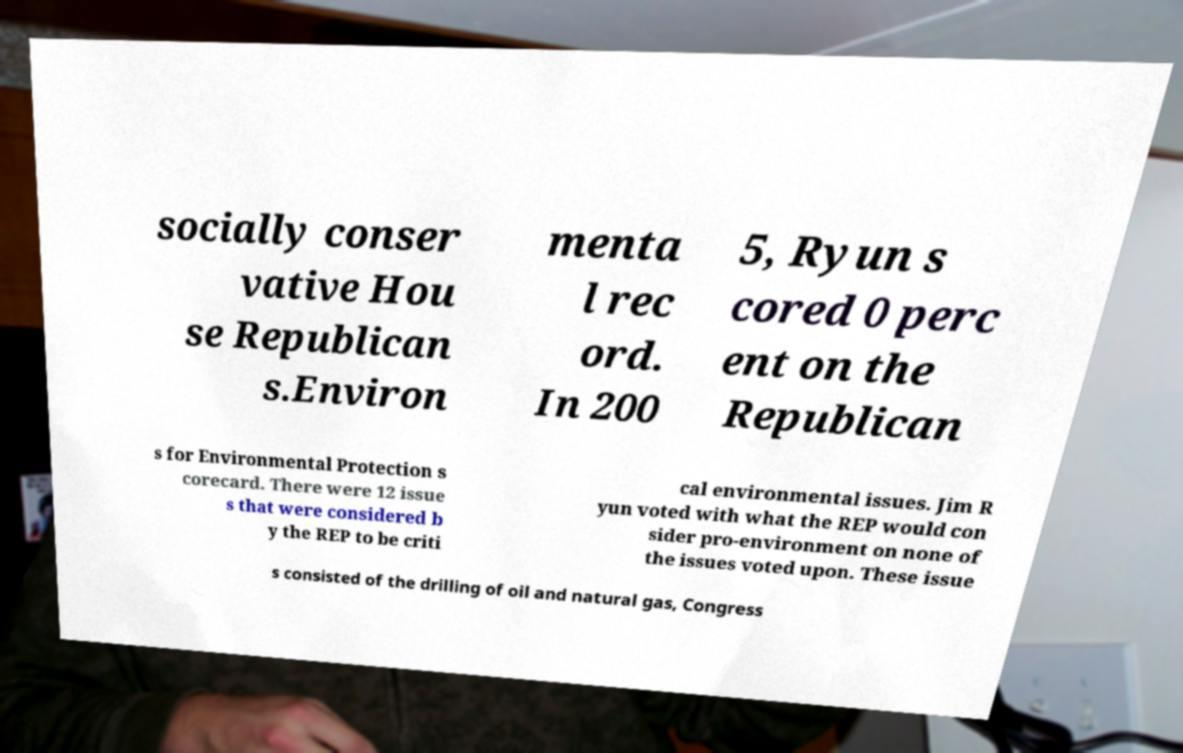Can you read and provide the text displayed in the image?This photo seems to have some interesting text. Can you extract and type it out for me? socially conser vative Hou se Republican s.Environ menta l rec ord. In 200 5, Ryun s cored 0 perc ent on the Republican s for Environmental Protection s corecard. There were 12 issue s that were considered b y the REP to be criti cal environmental issues. Jim R yun voted with what the REP would con sider pro-environment on none of the issues voted upon. These issue s consisted of the drilling of oil and natural gas, Congress 